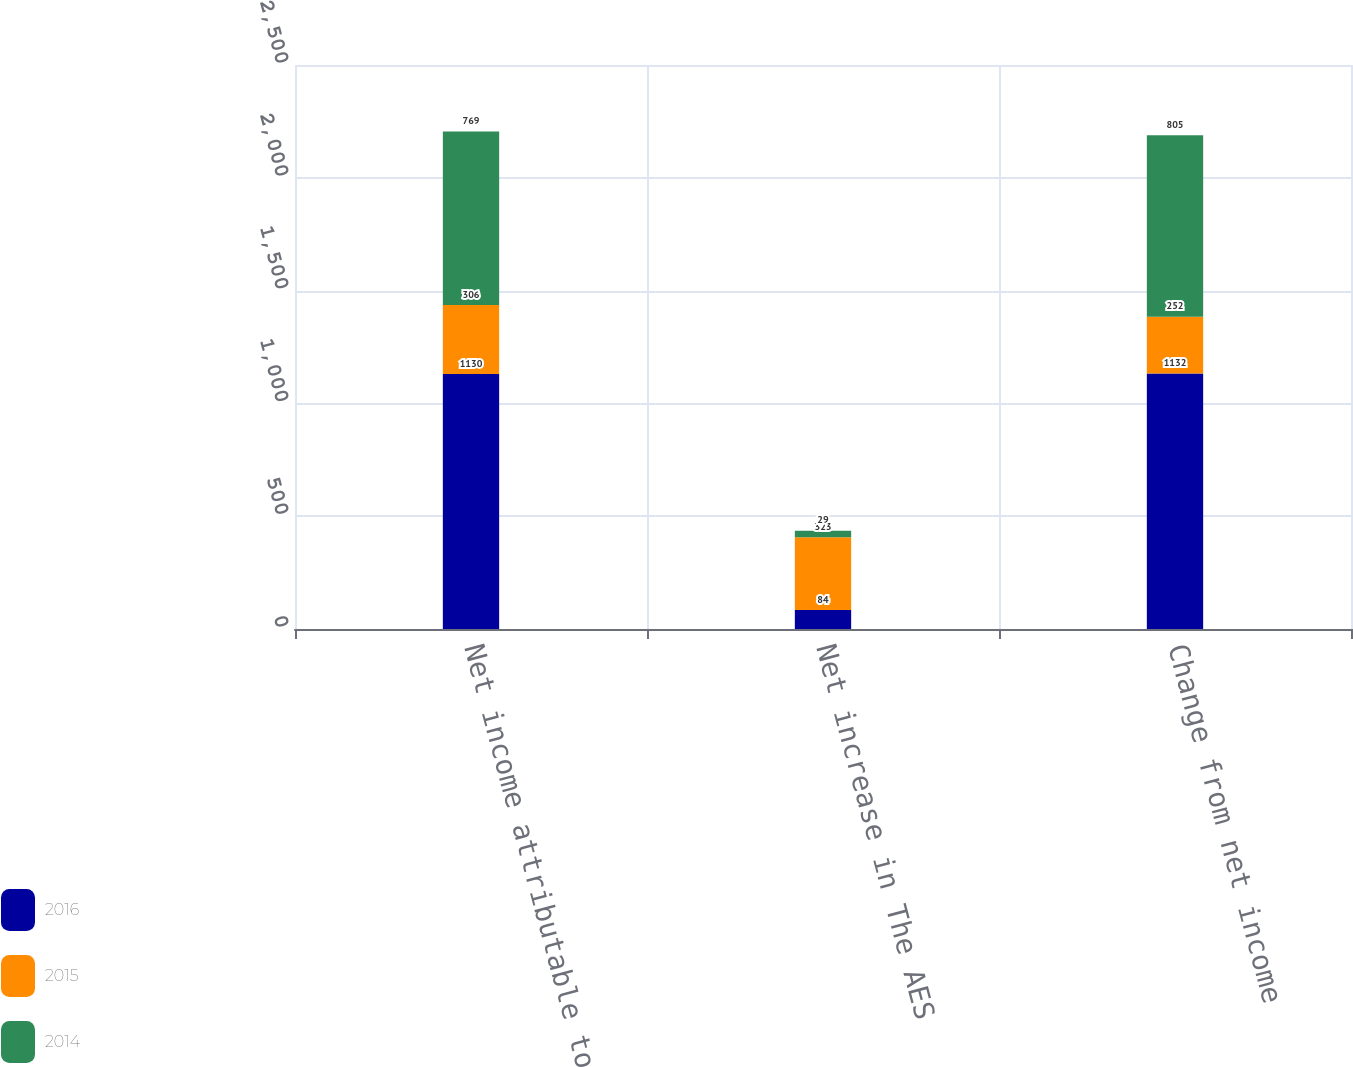Convert chart. <chart><loc_0><loc_0><loc_500><loc_500><stacked_bar_chart><ecel><fcel>Net income attributable to The<fcel>Net increase in The AES<fcel>Change from net income<nl><fcel>2016<fcel>1130<fcel>84<fcel>1132<nl><fcel>2015<fcel>306<fcel>323<fcel>252<nl><fcel>2014<fcel>769<fcel>29<fcel>805<nl></chart> 